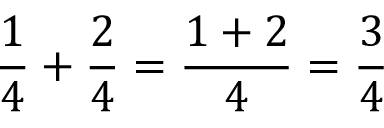<formula> <loc_0><loc_0><loc_500><loc_500>{ \frac { 1 } { 4 } } + { \frac { 2 } { 4 } } = { \frac { 1 + 2 } { 4 } } = { \frac { 3 } { 4 } }</formula> 